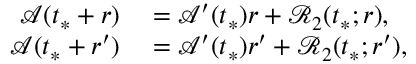Convert formula to latex. <formula><loc_0><loc_0><loc_500><loc_500>\begin{array} { r l } { \mathcal { A } ( t _ { * } + r ) } & = \mathcal { A } ^ { \prime } ( t _ { * } ) r + \mathcal { R } _ { 2 } ( t _ { * } ; r ) , } \\ { \mathcal { A } ( t _ { * } + r ^ { \prime } ) } & = \mathcal { A } ^ { \prime } ( t _ { * } ) r ^ { \prime } + \mathcal { R } _ { 2 } ( t _ { * } ; r ^ { \prime } ) , } \end{array}</formula> 